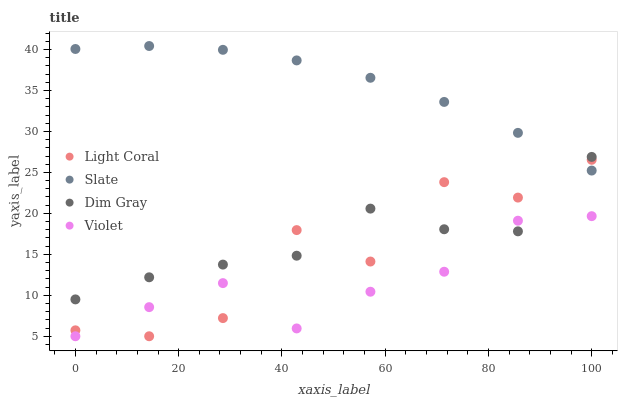Does Violet have the minimum area under the curve?
Answer yes or no. Yes. Does Slate have the maximum area under the curve?
Answer yes or no. Yes. Does Dim Gray have the minimum area under the curve?
Answer yes or no. No. Does Dim Gray have the maximum area under the curve?
Answer yes or no. No. Is Slate the smoothest?
Answer yes or no. Yes. Is Light Coral the roughest?
Answer yes or no. Yes. Is Dim Gray the smoothest?
Answer yes or no. No. Is Dim Gray the roughest?
Answer yes or no. No. Does Light Coral have the lowest value?
Answer yes or no. Yes. Does Dim Gray have the lowest value?
Answer yes or no. No. Does Slate have the highest value?
Answer yes or no. Yes. Does Dim Gray have the highest value?
Answer yes or no. No. Is Violet less than Slate?
Answer yes or no. Yes. Is Slate greater than Violet?
Answer yes or no. Yes. Does Dim Gray intersect Light Coral?
Answer yes or no. Yes. Is Dim Gray less than Light Coral?
Answer yes or no. No. Is Dim Gray greater than Light Coral?
Answer yes or no. No. Does Violet intersect Slate?
Answer yes or no. No. 